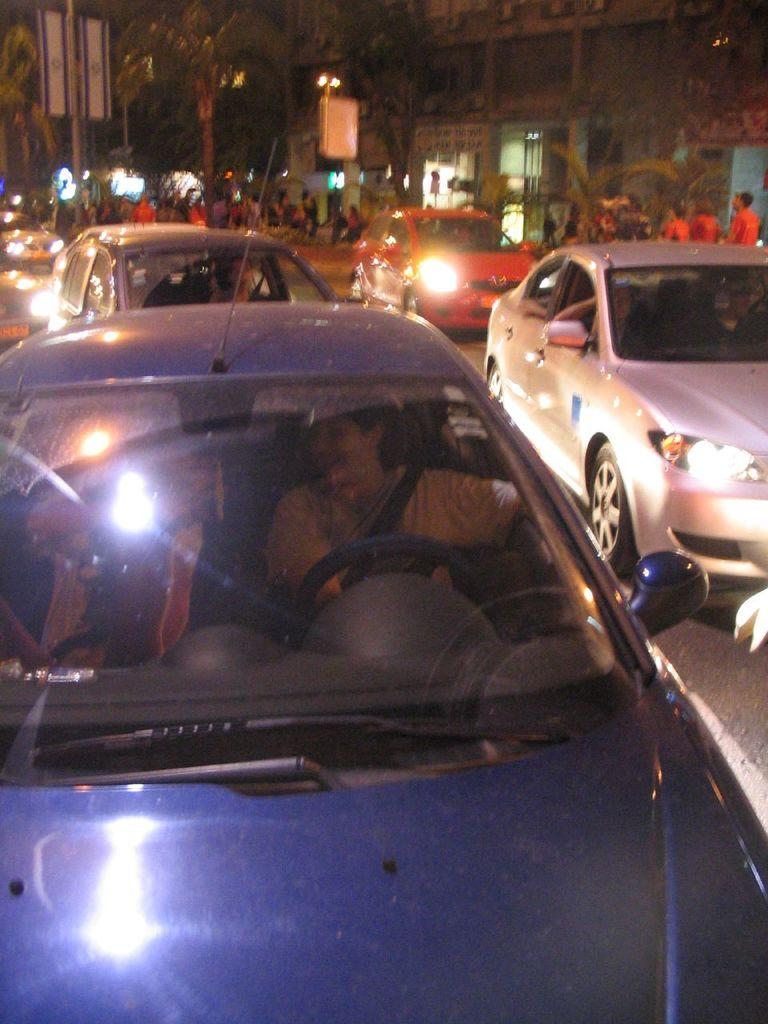What is the main feature of the image? There is a road in the image. What is happening on the road? Vehicles are moving on the road. Are there any people present in the image? Yes, people are walking at the side of the road. What can be seen in the background of the image? There are buildings, trees, and electric poles visible in the background. What type of mint is growing on the side of the road in the image? There is no mention of mint in the image, and no plants are described. 